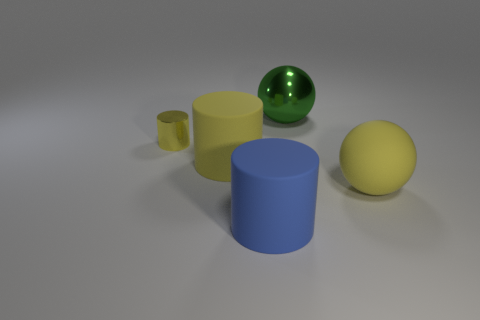Is there anything else of the same color as the big metal thing?
Offer a very short reply. No. What shape is the rubber object that is on the right side of the metallic thing that is to the right of the tiny yellow thing?
Give a very brief answer. Sphere. Are there fewer small yellow things than tiny brown metal cylinders?
Give a very brief answer. No. Is the material of the yellow ball the same as the green ball?
Provide a succinct answer. No. There is a cylinder that is to the left of the big blue object and on the right side of the yellow shiny cylinder; what is its color?
Provide a succinct answer. Yellow. Are there any other balls that have the same size as the green metal sphere?
Your answer should be very brief. Yes. How big is the yellow ball in front of the rubber object that is behind the big rubber sphere?
Offer a very short reply. Large. Are there fewer balls to the right of the yellow ball than cylinders?
Your answer should be very brief. Yes. Do the tiny cylinder and the large matte sphere have the same color?
Your answer should be compact. Yes. What is the size of the blue matte cylinder?
Provide a short and direct response. Large. 